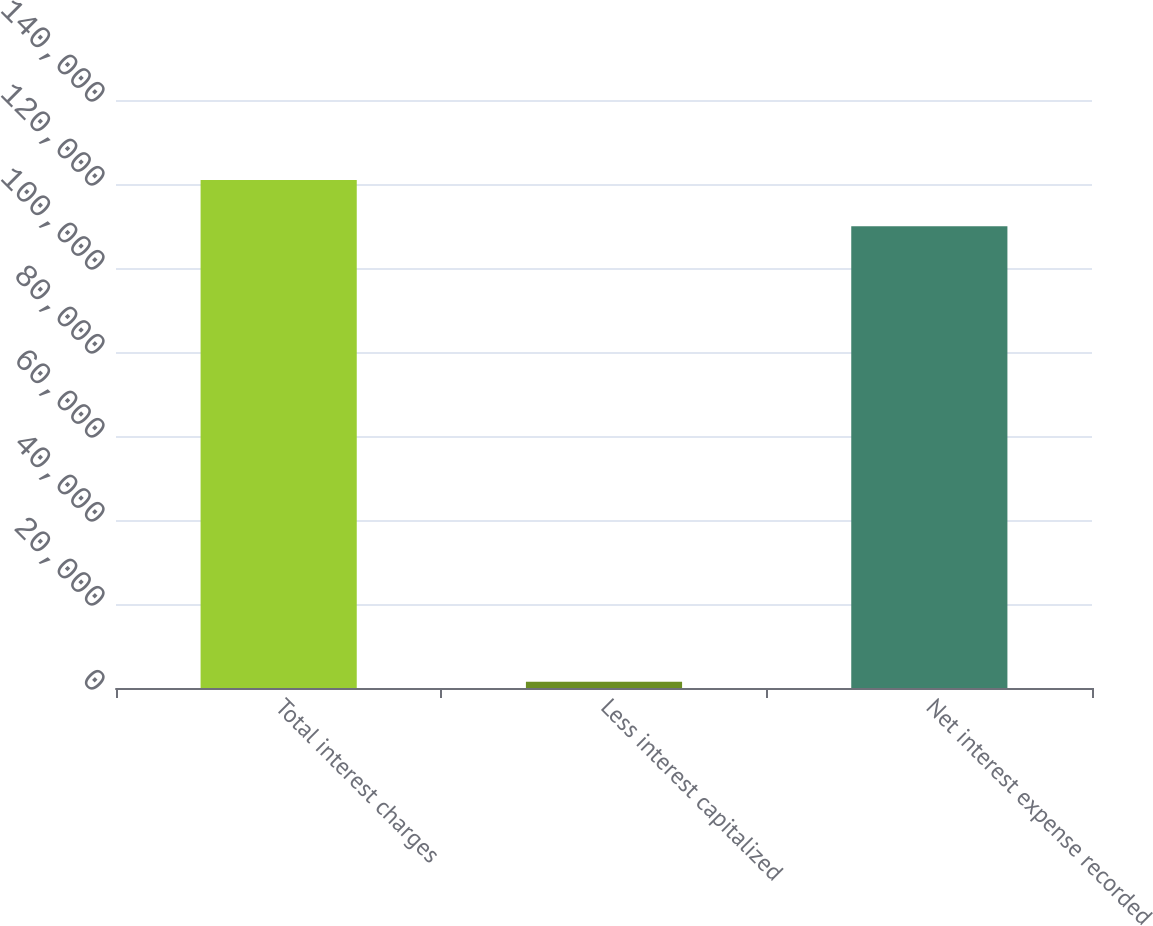Convert chart to OTSL. <chart><loc_0><loc_0><loc_500><loc_500><bar_chart><fcel>Total interest charges<fcel>Less interest capitalized<fcel>Net interest expense recorded<nl><fcel>120956<fcel>1473<fcel>109960<nl></chart> 